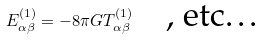Convert formula to latex. <formula><loc_0><loc_0><loc_500><loc_500>E _ { \alpha \beta } ^ { ( 1 ) } = - 8 \pi G T _ { \alpha \beta } ^ { ( 1 ) } \quad \text {, etc\dots}</formula> 